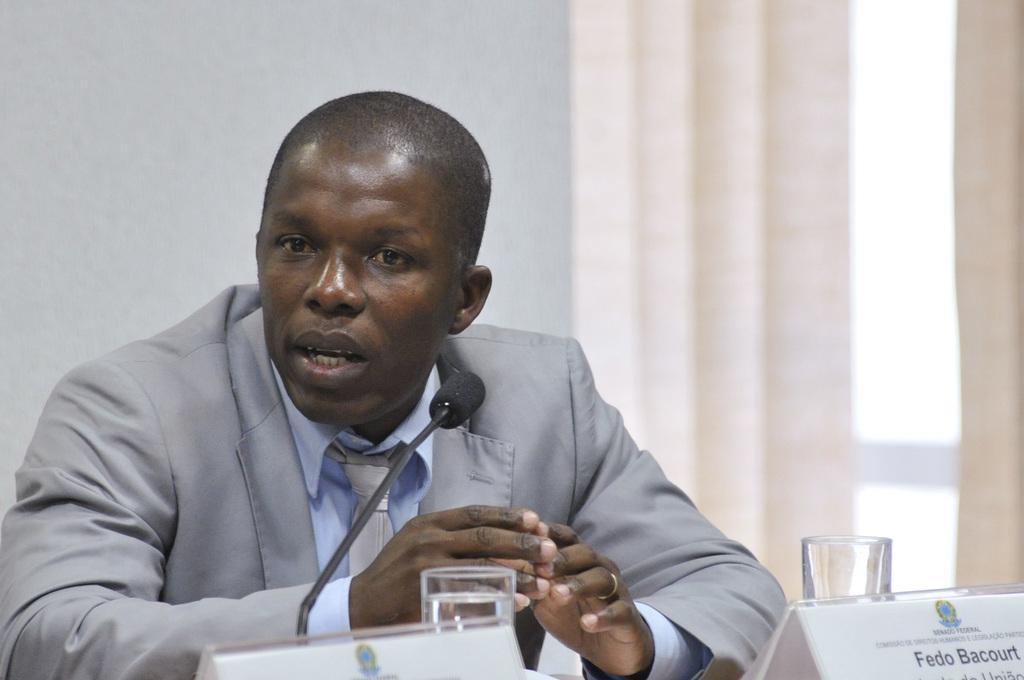Please provide a concise description of this image. In the picture we can see a man sitting near the desk, he is in a blazer, tie and shirt and on the desk we can see two glasses of water, name boards, and a microphone and in the background we can see the wall. 